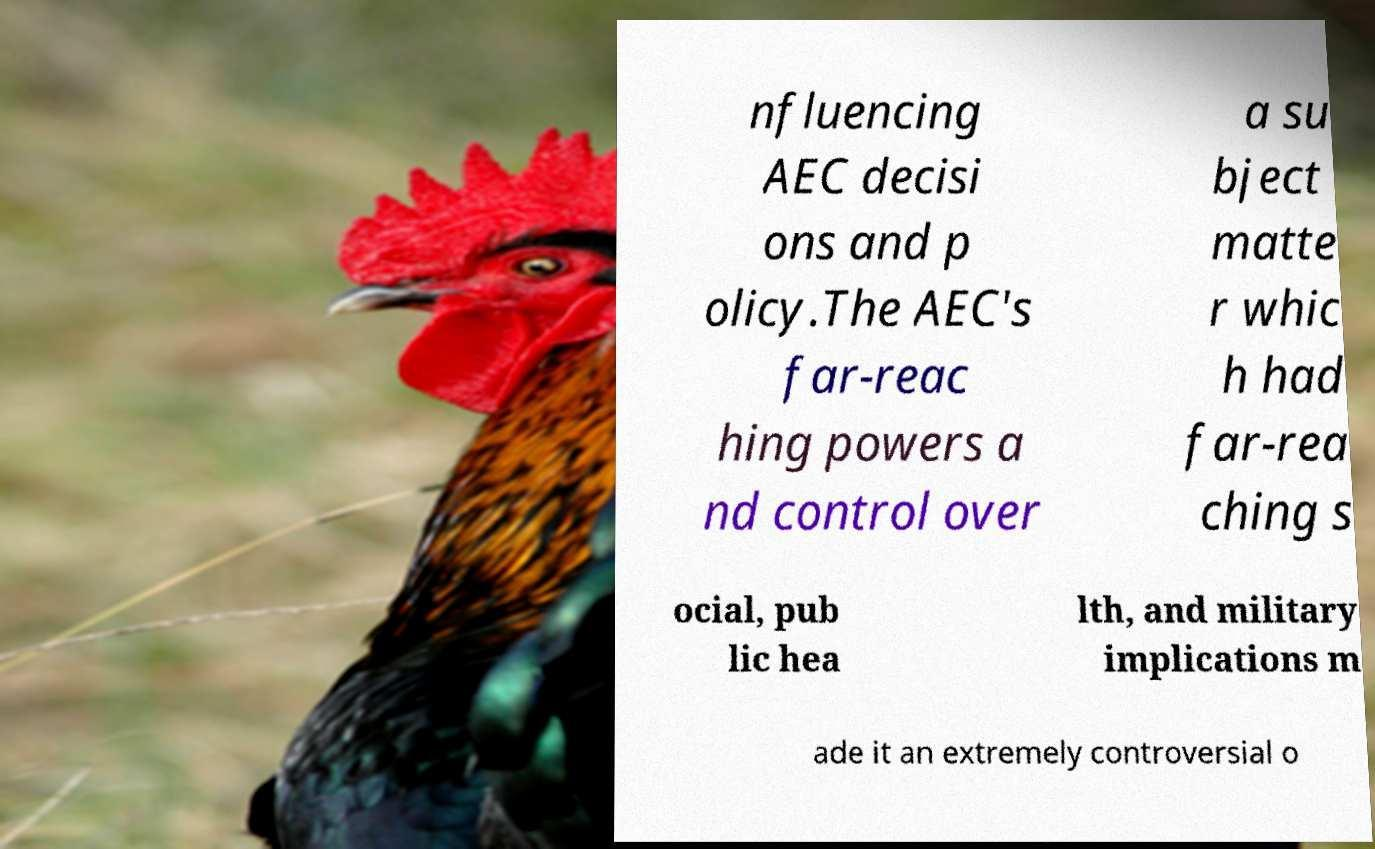I need the written content from this picture converted into text. Can you do that? nfluencing AEC decisi ons and p olicy.The AEC's far-reac hing powers a nd control over a su bject matte r whic h had far-rea ching s ocial, pub lic hea lth, and military implications m ade it an extremely controversial o 